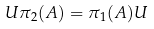<formula> <loc_0><loc_0><loc_500><loc_500>U \pi _ { 2 } ( A ) = \pi _ { 1 } ( A ) U</formula> 